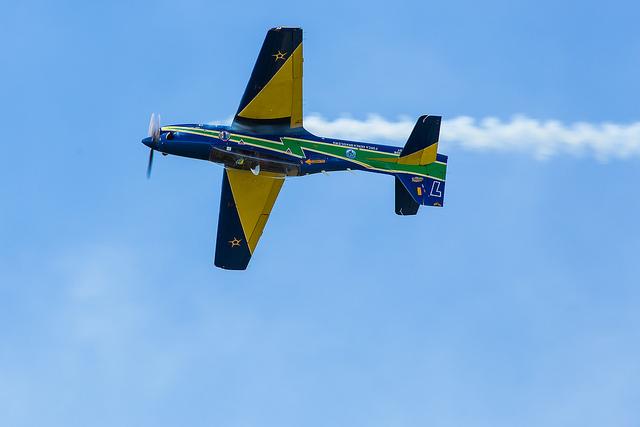Is the airplane upside down?
Short answer required. Yes. What kind of plane is this?
Be succinct. Jet. Is the airplane blowing smoke?
Quick response, please. Yes. Are these Blue Angels "stacked"?
Quick response, please. No. 